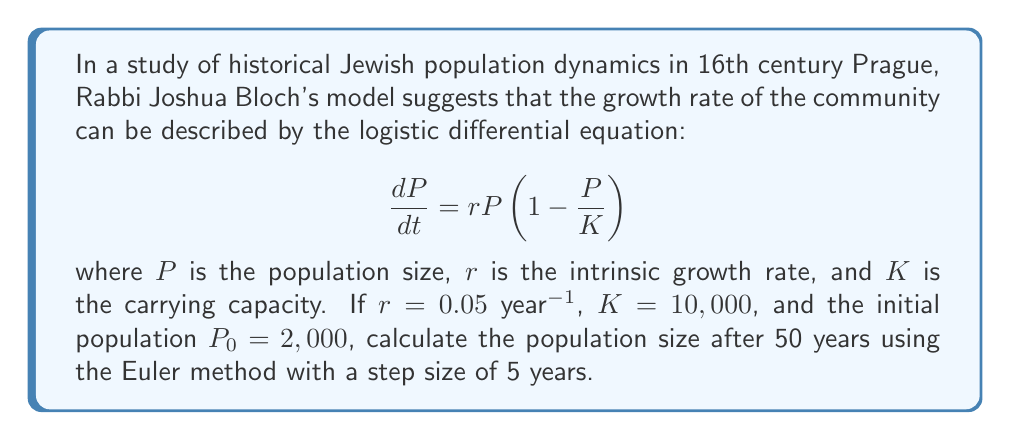Give your solution to this math problem. To solve this problem, we'll use the Euler method to approximate the solution of the differential equation. The Euler method is given by:

$$P_{n+1} = P_n + h \cdot f(t_n, P_n)$$

where $h$ is the step size, and $f(t, P) = rP(1 - \frac{P}{K})$ is the right-hand side of the differential equation.

Given:
- $r = 0.05$ year$^{-1}$
- $K = 10,000$
- $P_0 = 2,000$
- Step size $h = 5$ years
- Total time $T = 50$ years

Number of steps: $n = T/h = 50/5 = 10$

Let's calculate the population for each step:

1. $P_0 = 2,000$
2. $P_1 = P_0 + h \cdot r P_0 (1 - \frac{P_0}{K}) = 2,000 + 5 \cdot 0.05 \cdot 2,000 (1 - \frac{2,000}{10,000}) = 2,300$
3. $P_2 = 2,300 + 5 \cdot 0.05 \cdot 2,300 (1 - \frac{2,300}{10,000}) = 2,622.75$
4. $P_3 = 2,622.75 + 5 \cdot 0.05 \cdot 2,622.75 (1 - \frac{2,622.75}{10,000}) = 2,965.80$
5. $P_4 = 2,965.80 + 5 \cdot 0.05 \cdot 2,965.80 (1 - \frac{2,965.80}{10,000}) = 3,326.72$
6. $P_5 = 3,326.72 + 5 \cdot 0.05 \cdot 3,326.72 (1 - \frac{3,326.72}{10,000}) = 3,702.89$
7. $P_6 = 3,702.89 + 5 \cdot 0.05 \cdot 3,702.89 (1 - \frac{3,702.89}{10,000}) = 4,091.60$
8. $P_7 = 4,091.60 + 5 \cdot 0.05 \cdot 4,091.60 (1 - \frac{4,091.60}{10,000}) = 4,489.97$
9. $P_8 = 4,489.97 + 5 \cdot 0.05 \cdot 4,489.97 (1 - \frac{4,489.97}{10,000}) = 4,894.98$
10. $P_9 = 4,894.98 + 5 \cdot 0.05 \cdot 4,894.98 (1 - \frac{4,894.98}{10,000}) = 5,303.37$
11. $P_{10} = 5,303.37 + 5 \cdot 0.05 \cdot 5,303.37 (1 - \frac{5,303.37}{10,000}) = 5,711.74$

Therefore, after 50 years, the population size is approximately 5,712 (rounded to the nearest integer).
Answer: 5,712 